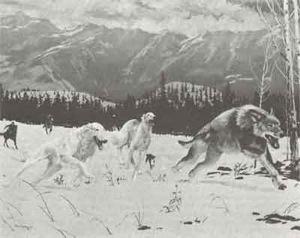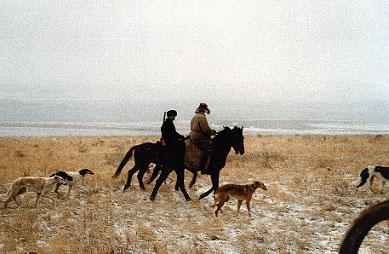The first image is the image on the left, the second image is the image on the right. Given the left and right images, does the statement "An image features a horse rearing up with raised front legs, behind multiple dogs." hold true? Answer yes or no. No. The first image is the image on the left, the second image is the image on the right. Evaluate the accuracy of this statement regarding the images: "In one of the images there is a man sitting on top of a dog.". Is it true? Answer yes or no. No. 